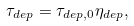Convert formula to latex. <formula><loc_0><loc_0><loc_500><loc_500>\tau _ { d e p } = \tau _ { d e p , 0 } \eta _ { d e p } ,</formula> 